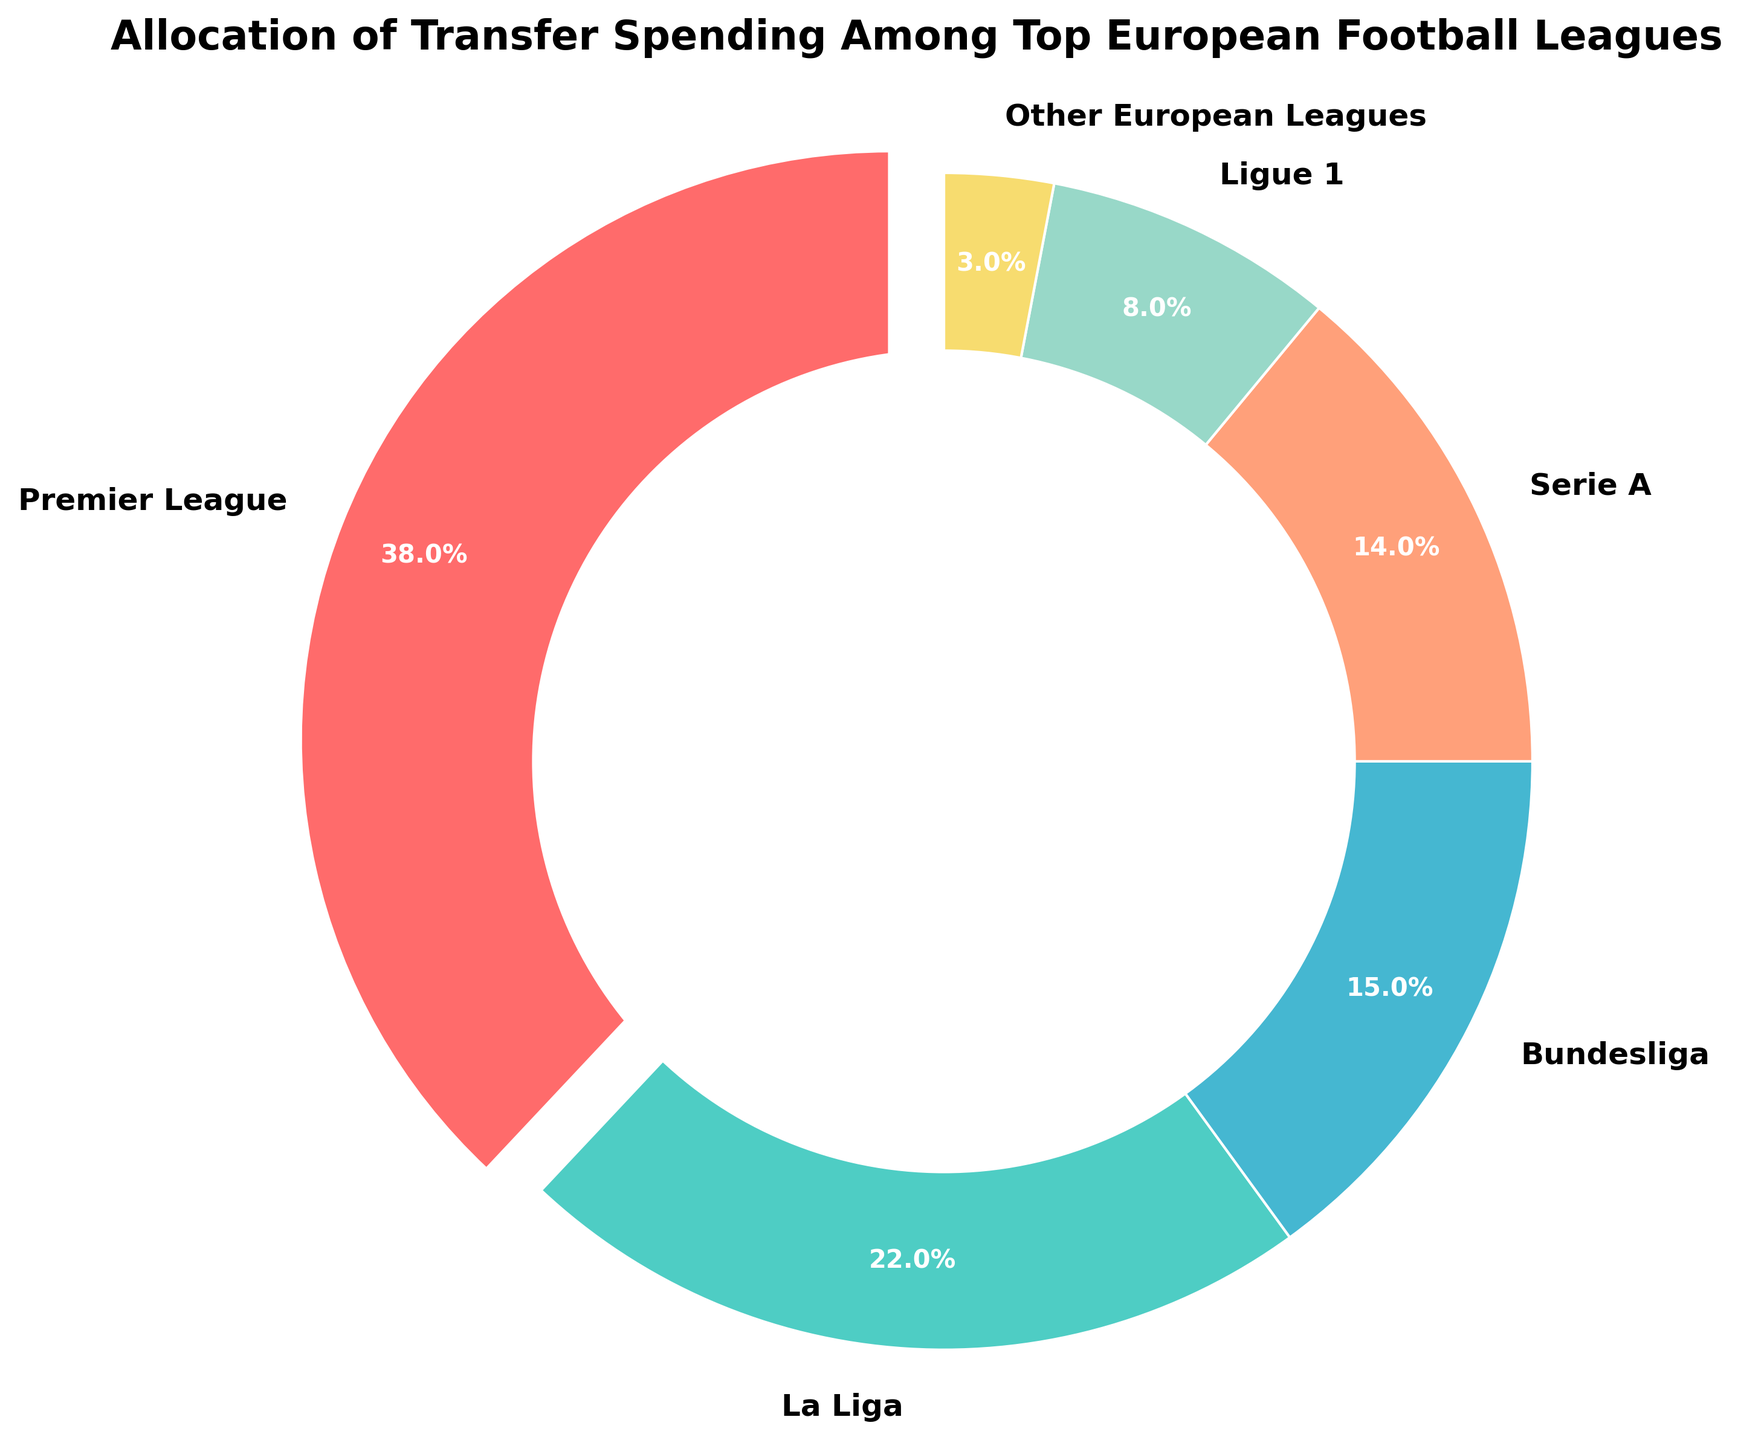Which league has the highest transfer spending percentage? The pie chart shows various leagues and their transfer spending percentages. The Premier League occupies the largest section of the pie.
Answer: Premier League Which league has the lowest transfer spending percentage among the top European leagues? Looking at each section of the pie chart, the smallest section represents "Other European Leagues" with 3%.
Answer: Other European Leagues How much higher is the Premier League's transfer spending percentage compared to Ligue 1? The Premier League has 38% and Ligue 1 has 8% spending. The difference is 38% - 8% = 30%.
Answer: 30% What is the total transfer spending percentage of La Liga, Bundesliga, and Serie A combined? La Liga has 22%, Bundesliga has 15%, and Serie A has 14%. Summing these percentages: 22% + 15% + 14% = 51%.
Answer: 51% Which league has a higher transfer spending percentage, Bundesliga or La Liga? Comparing the sections of the chart, La Liga has 22% and Bundesliga has 15%. La Liga is higher.
Answer: La Liga What percentage of the transfer spending is allocated to leagues outside of the top five European leagues? The chart lists "Other European Leagues" at 3%.
Answer: 3% How does the transfer spending of Serie A compare to that of Ligue 1 and Other European Leagues combined? Serie A has 14%. Ligue 1 has 8% and Other European Leagues have 3%, combining to 8% + 3% = 11%. Serie A's percentage is higher.
Answer: Serie A's percentage is higher What is the difference in transfer spending percentages between the league with the second highest and the league with the third highest transfer spending? La Liga has the second highest percentage at 22% and Bundesliga has the third highest at 15%. The difference is 22% - 15% = 7%.
Answer: 7% Which color represents the Ligue 1 in the pie chart? By looking at the pie chart, Ligue 1 is represented by the color corresponding to its section, which is a light green-ish color.
Answer: Light green If percentages for Premier League and La Liga are combined, will they together exceed the sum of all other leagues? Premier League is 38% and La Liga is 22%, summing up to 38% + 22% = 60%. All other leagues combined give: Bundesliga 15% + Serie A 14% + Ligue 1 8% + Other European Leagues 3% = 40%. So, 60% > 40%.
Answer: Yes 